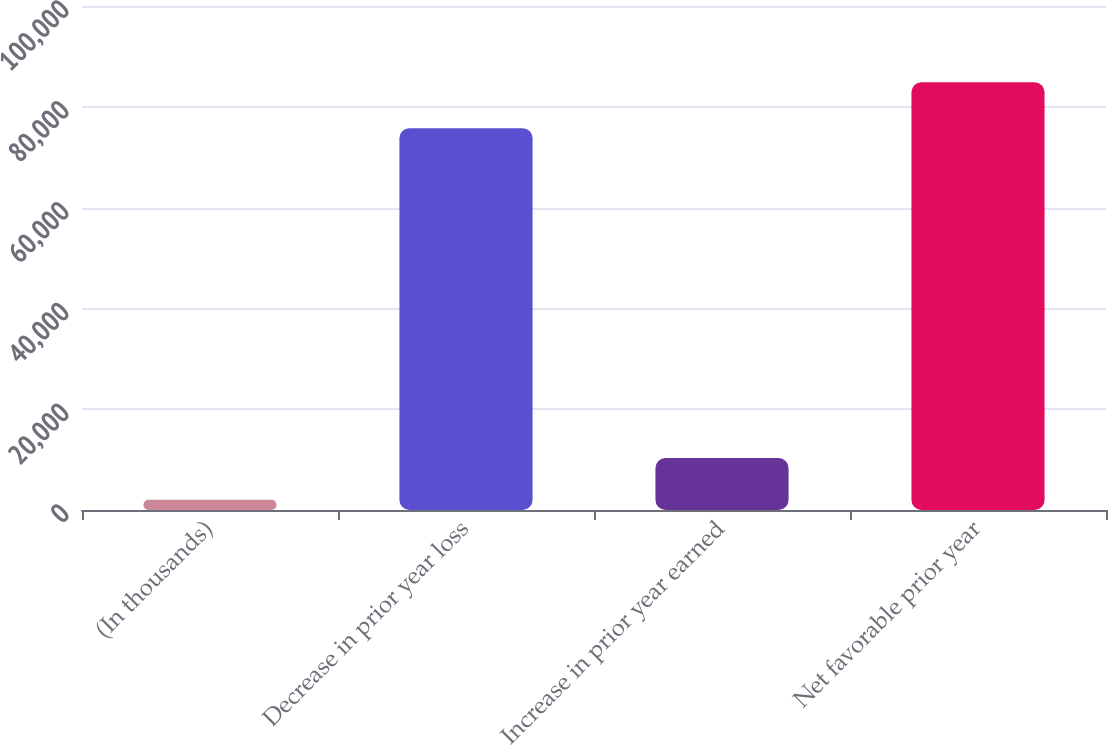<chart> <loc_0><loc_0><loc_500><loc_500><bar_chart><fcel>(In thousands)<fcel>Decrease in prior year loss<fcel>Increase in prior year earned<fcel>Net favorable prior year<nl><fcel>2014<fcel>75764<fcel>10297.8<fcel>84852<nl></chart> 